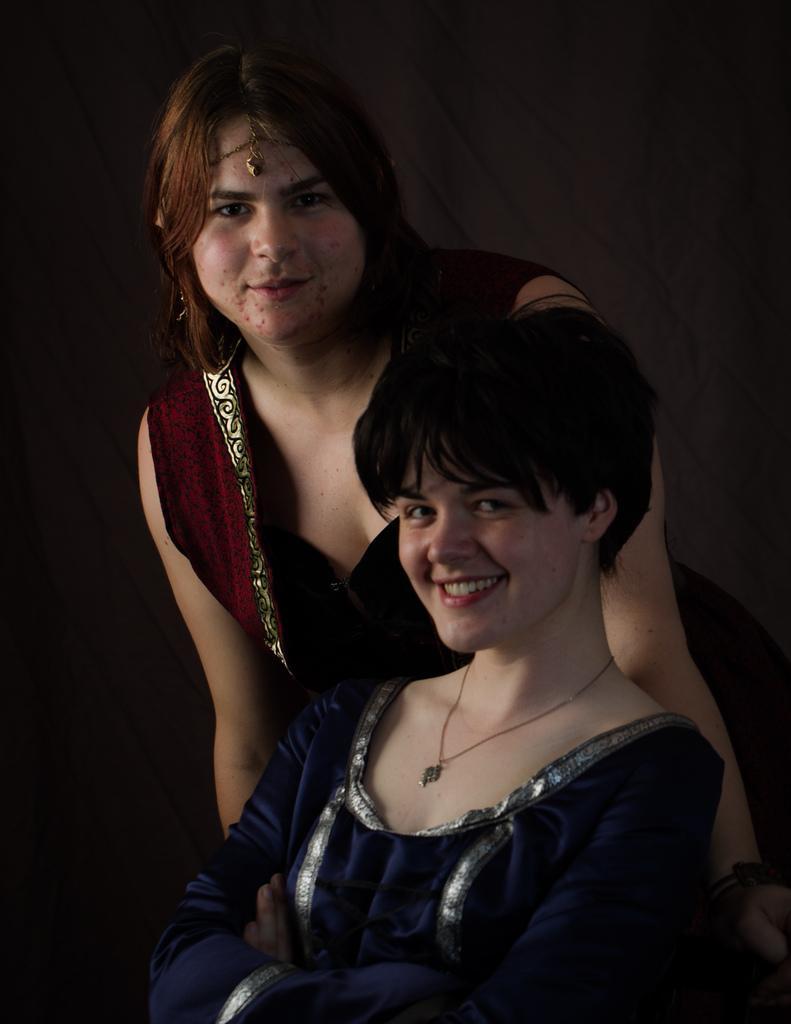Please provide a concise description of this image. In this image we can see two people, a person is sitting and a person is standing behind the person. 